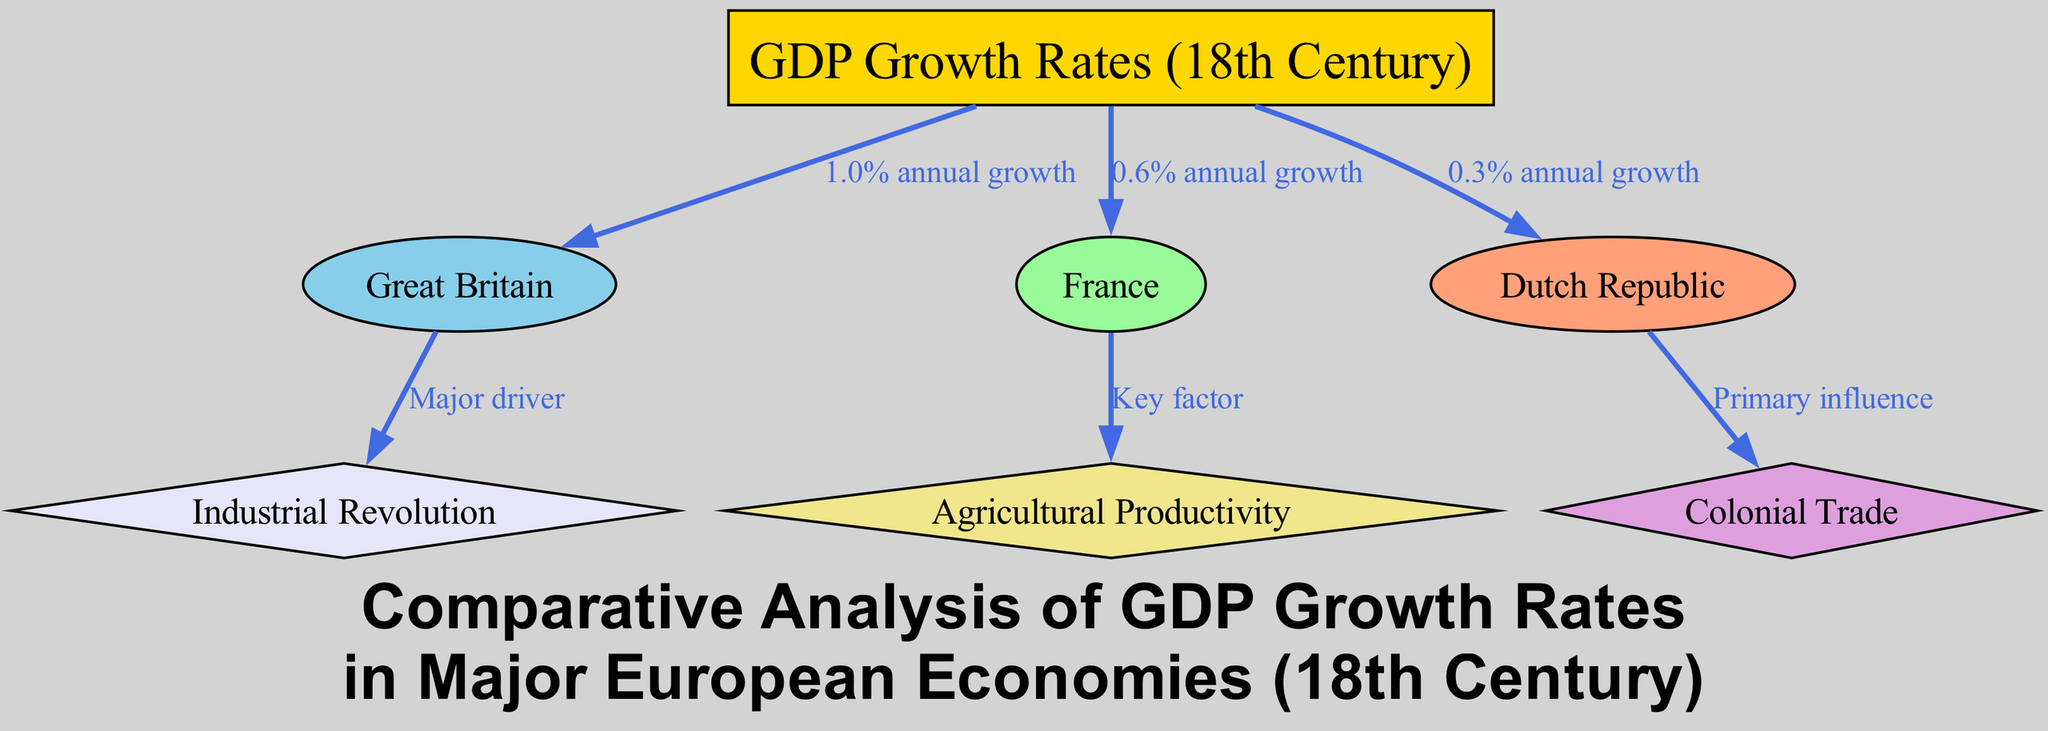What is the GDP growth rate for Great Britain during the 18th century? The diagram shows an edge connecting the GDP Growth Rates node to Great Britain, which is labeled with "1.0% annual growth". This indicates that Great Britain's GDP growth rate during this period is 1.0%.
Answer: 1.0% annual growth What is the lowest GDP growth rate mentioned in the diagram? The diagram displays three nodes with growth rates: Great Britain (1.0%), France (0.6%), and the Dutch Republic (0.3%). The node for the Dutch Republic has the lowest value labeled "0.3% annual growth".
Answer: 0.3% annual growth Which economy is linked to the Industrial Revolution? The diagram has an edge from the Great Britain node to the Industrial Revolution node, labeled "Major driver". This indicates that Great Britain’s GDP growth was primarily driven by the Industrial Revolution.
Answer: Great Britain What relationship does France have with agricultural productivity? The diagram shows an edge from France to Agricultural Productivity, labeled "Key factor". This implies that agricultural productivity is an important factor influencing the GDP growth of France.
Answer: Key factor What is the primary influence for the Dutch Republic's GDP growth? The connection between the Dutch Republic and Colonial Trade is indicated in the diagram with the label "Primary influence". This highlights that colonial trade served as the main factor contributing to the GDP growth of the Dutch Republic.
Answer: Primary influence How many nodes are there in the diagram? The diagram contains a total of seven nodes: one for GDP Growth Rates, three representing the economies (Great Britain, France, and Dutch Republic), and three for the influencing factors (Industrial Revolution, Agricultural Productivity, Colonial Trade). Counting these results in seven nodes.
Answer: 7 What does the label on the edge from GDP Growth Rates to France indicate? The edge leading to France is labeled "0.6% annual growth", which shows the specific annual GDP growth rate associated with France during the 18th century.
Answer: 0.6% annual growth Which economy has the highest GDP growth rate? Looking at the edges leading from the GDP Growth Rates node, Great Britain has the highest value of "1.0% annual growth", which is greater than both France's and the Dutch Republic's growth rates.
Answer: Great Britain What type of diagram is being used in this analysis? The structure presented in this analysis, which demonstrates relationships through nodes and edges, is characteristic of a directed graph. This displays various connections between GDP growth rates and economic factors influencing them.
Answer: Directed graph 